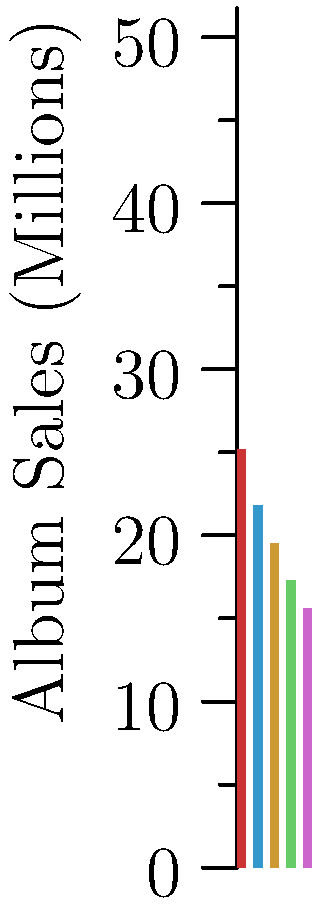Based on the chart showing album sales of top 80s pop artists, which two artists have a combined album sales total closest to 40 million? To solve this problem, we need to:

1. Identify the album sales for each artist:
   - Michael Jackson: 25.2 million
   - Madonna: 21.8 million
   - Prince: 19.5 million
   - Whitney Houston: 17.3 million
   - Cyndi Lauper: 15.6 million

2. Calculate different combinations of two artists' sales and find which sum is closest to 40 million:

   a) Michael Jackson + Madonna: 25.2 + 21.8 = 47.0 million
   b) Michael Jackson + Prince: 25.2 + 19.5 = 44.7 million
   c) Michael Jackson + Whitney Houston: 25.2 + 17.3 = 42.5 million
   d) Michael Jackson + Cyndi Lauper: 25.2 + 15.6 = 40.8 million
   e) Madonna + Prince: 21.8 + 19.5 = 41.3 million
   f) Madonna + Whitney Houston: 21.8 + 17.3 = 39.1 million
   g) Madonna + Cyndi Lauper: 21.8 + 15.6 = 37.4 million
   h) Prince + Whitney Houston: 19.5 + 17.3 = 36.8 million
   i) Prince + Cyndi Lauper: 19.5 + 15.6 = 35.1 million
   j) Whitney Houston + Cyndi Lauper: 17.3 + 15.6 = 32.9 million

3. Compare the results to 40 million and find the closest:
   The combination closest to 40 million is Madonna + Whitney Houston at 39.1 million.
Answer: Madonna and Whitney Houston 